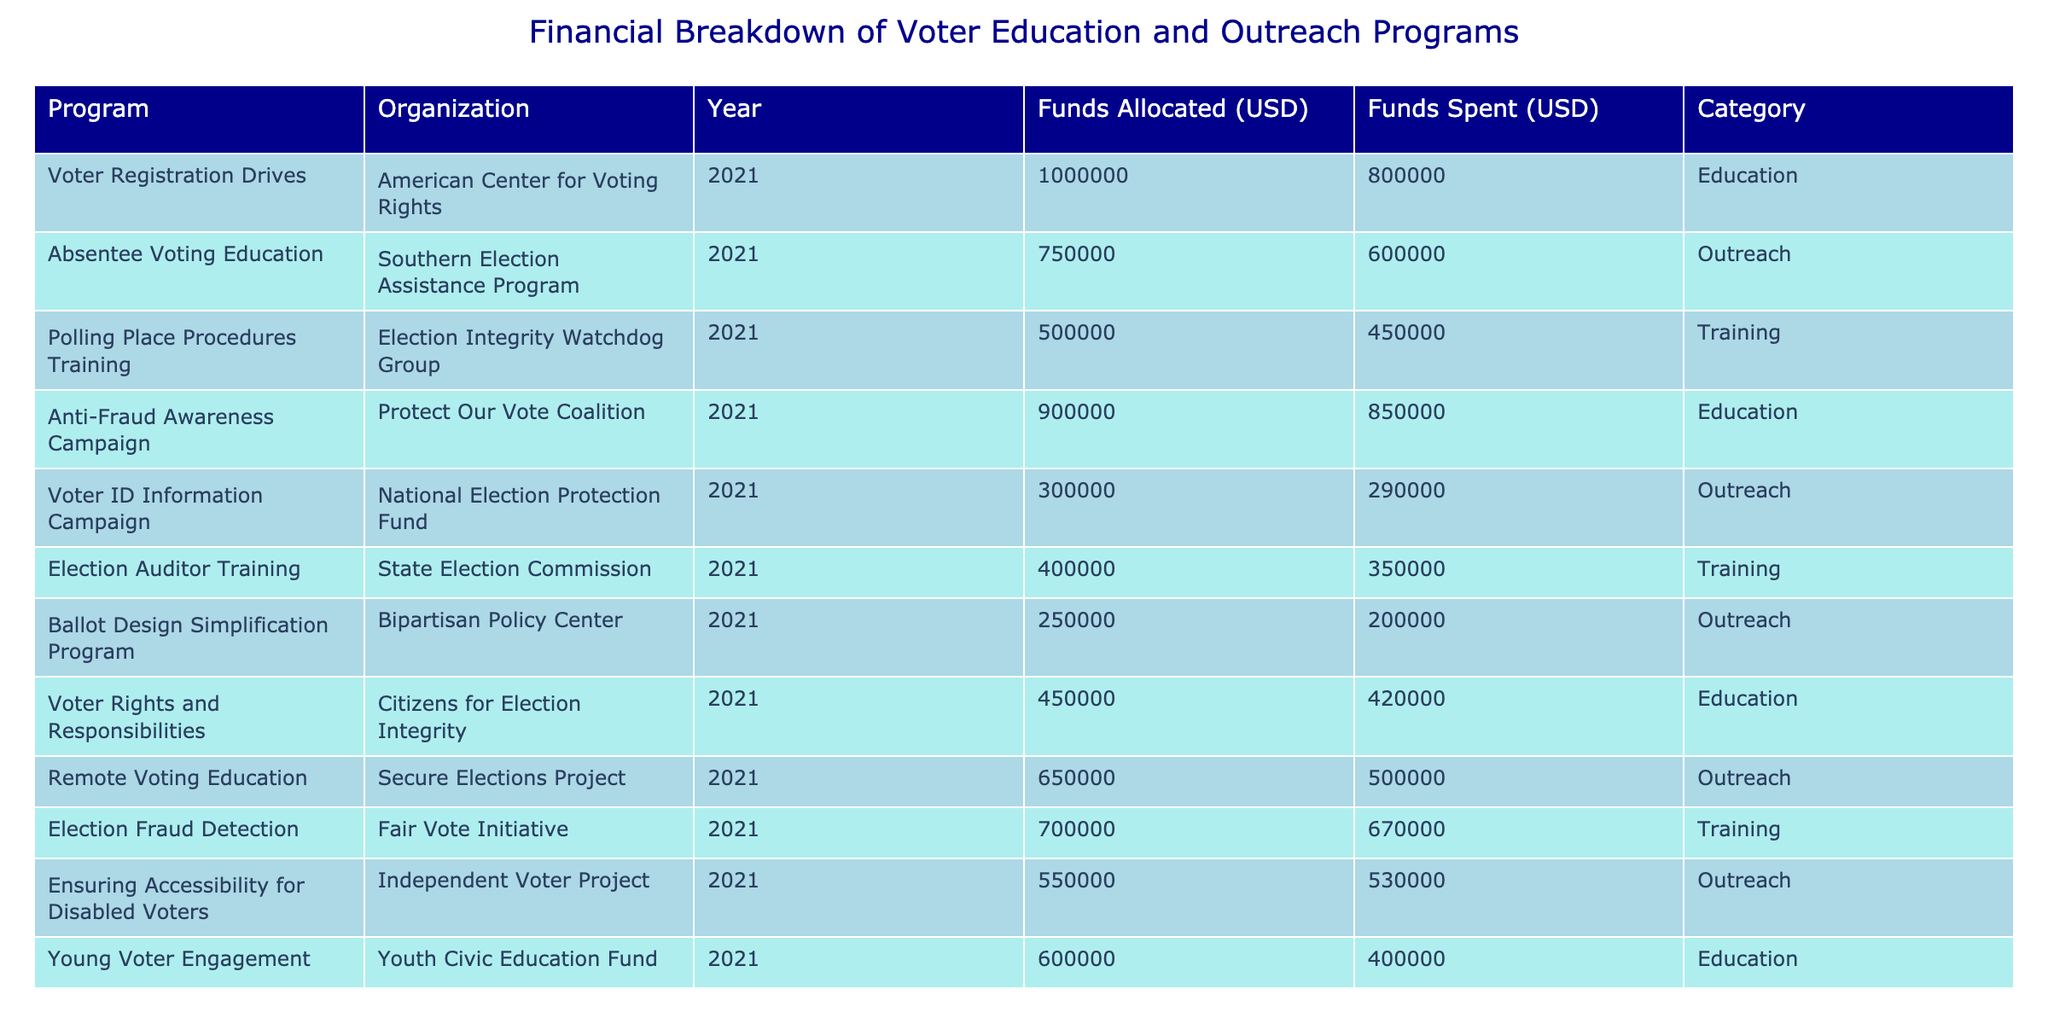What is the total amount allocated for Voter Registration Drives? The table shows that the allocated amount for Voter Registration Drives is listed under the "Funds Allocated (USD)" column. The value is 1,000,000.
Answer: 1,000,000 What is the difference between the funds allocated and funds spent for the Anti-Fraud Awareness Campaign? According to the table, the funds allocated for the Anti-Fraud Awareness Campaign is 900,000 and the funds spent is 850,000. The difference is 900,000 - 850,000 = 50,000.
Answer: 50,000 Which program had the highest funds spent in 2021? Looking through the "Funds Spent (USD)" column, the program with the highest funds spent is the Anti-Fraud Awareness Campaign, which has 850,000.
Answer: Anti-Fraud Awareness Campaign Is the total amount spent on outreach programs greater than 2 million? The total amount spent on outreach programs can be calculated by adding the spent amounts from relevant programs: 600,000 (Absentee Voting Education) + 290,000 (Voter ID Information Campaign) + 200,000 (Ballot Design Simplification Program) + 500,000 (Remote Voting Education) + 530,000 (Ensuring Accessibility for Disabled Voters) = 2,120,000, which is indeed greater than 2 million.
Answer: Yes What is the average amount spent on training programs? The training programs and their spent amounts are: 450,000 (Polling Place Procedures Training), 350,000 (Election Auditor Training), and 670,000 (Election Fraud Detection). To find the average, sum these amounts: 450,000 + 350,000 + 670,000 = 1,470,000. Divide by 3 (the number of training programs), giving 1,470,000 / 3 = 490,000.
Answer: 490,000 Was any money unspent in the Young Voter Engagement program? The table shows that the funds allocated for Young Voter Engagement is 600,000 and the funds spent is 400,000. Thus, there is an unspent amount of 600,000 - 400,000 = 200,000, indicating that money was indeed left unspent.
Answer: Yes How much funding did the Secure Elections Project receive, and what was its spending status? The Secure Elections Project received 650,000 in funding and spent 500,000. The spending status shows that there was an unspent amount of 650,000 - 500,000 = 150,000.
Answer: Received 650,000, spent 500,000 What proportion of funds was spent on voter education programs compared to the total funds allocated? The total funds allocated for education programs are 1,000,000 (Voter Registration Drives) + 900,000 (Anti-Fraud Awareness Campaign) + 450,000 (Voter Rights and Responsibilities) + 600,000 (Young Voter Engagement) = 2,950,000. The total allocated amount is 1,000,000 + 750,000 + 500,000 + 900,000 + 300,000 + 400,000 + 250,000 + 450,000 + 650,000 + 700,000 + 550,000 + 600,000 = 6,750,000. Funds spent on education programs amount to 800,000 + 850,000 + 420,000 + 400,000 = 2,470,000. Therefore, the proportion of funds spent on education programs is 2,470,000 / 6,750,000 = approximately 0.366 or 36.6%.
Answer: Approximately 36.6% 